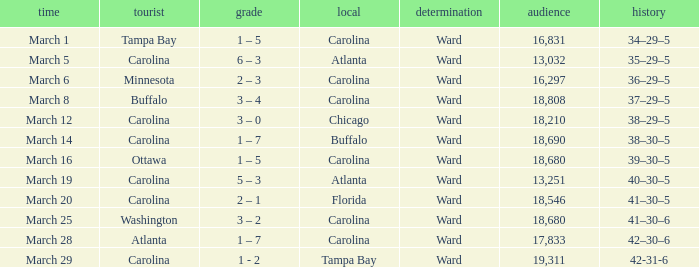What is the Record when Buffalo is at Home? 38–30–5. 